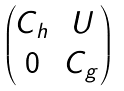Convert formula to latex. <formula><loc_0><loc_0><loc_500><loc_500>\begin{pmatrix} C _ { h } & U \\ 0 & C _ { g } \\ \end{pmatrix}</formula> 